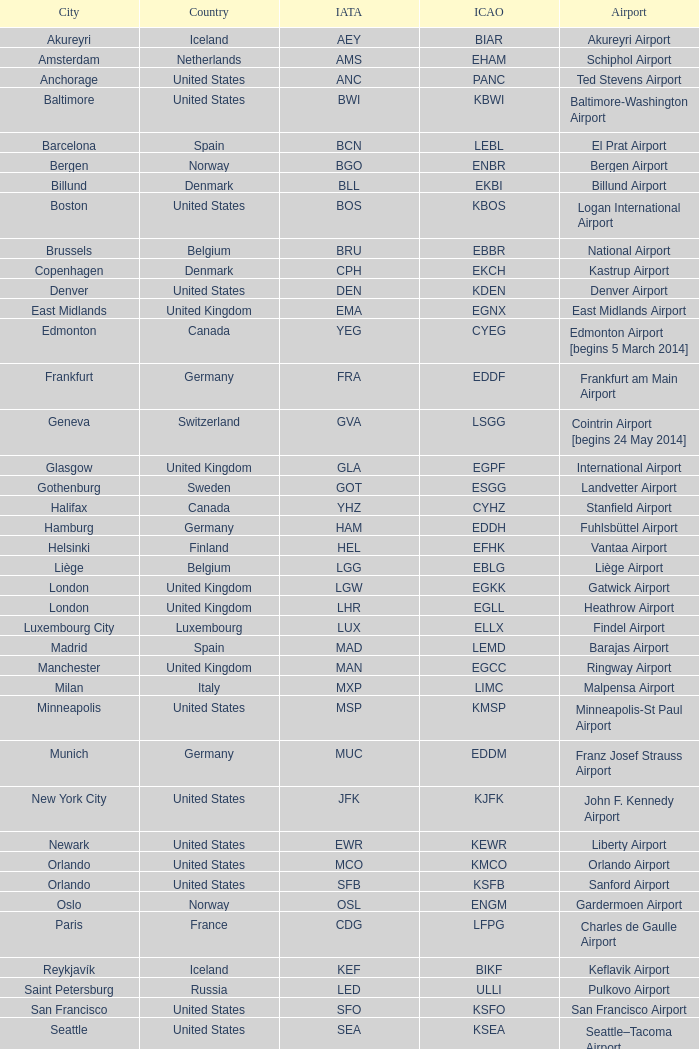Which airport is represented by the sea iata code? Seattle–Tacoma Airport. 